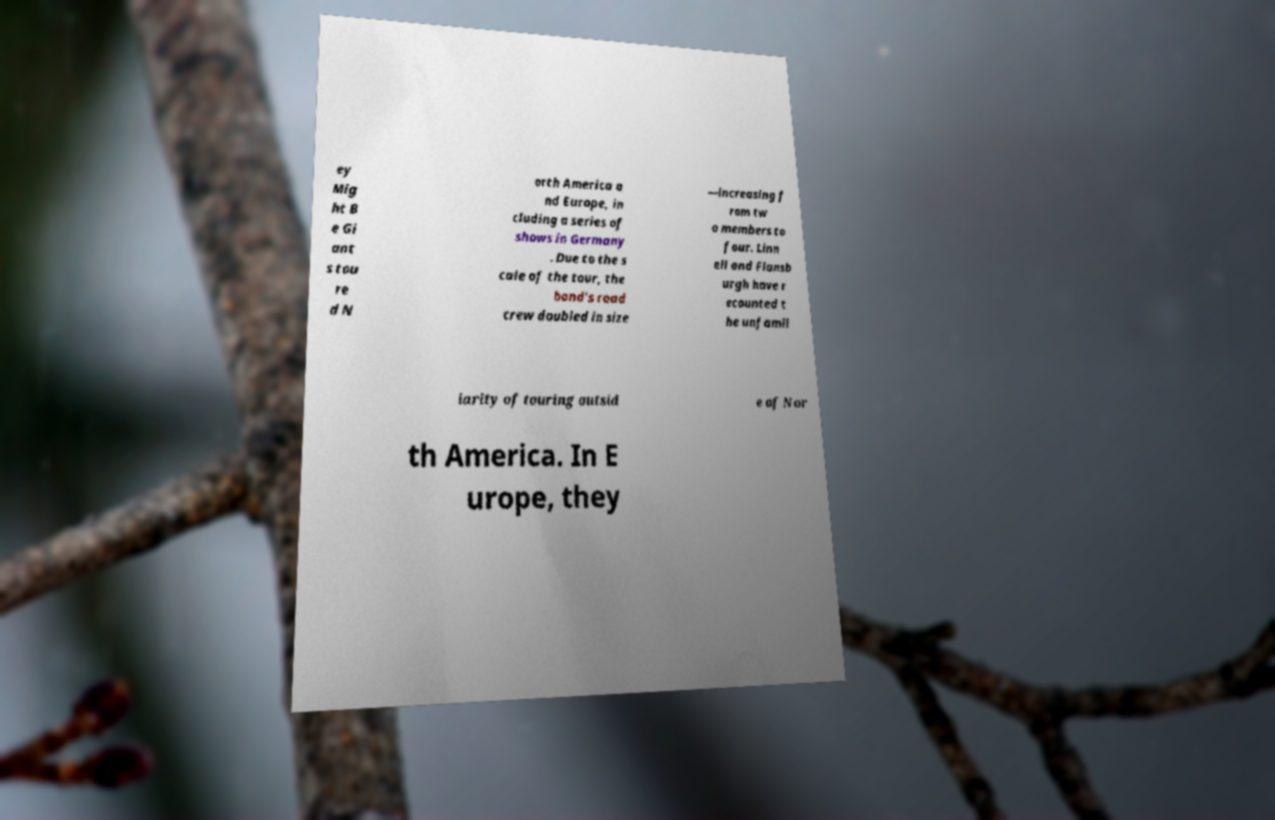Could you extract and type out the text from this image? ey Mig ht B e Gi ant s tou re d N orth America a nd Europe, in cluding a series of shows in Germany . Due to the s cale of the tour, the band's road crew doubled in size —increasing f rom tw o members to four. Linn ell and Flansb urgh have r ecounted t he unfamil iarity of touring outsid e of Nor th America. In E urope, they 